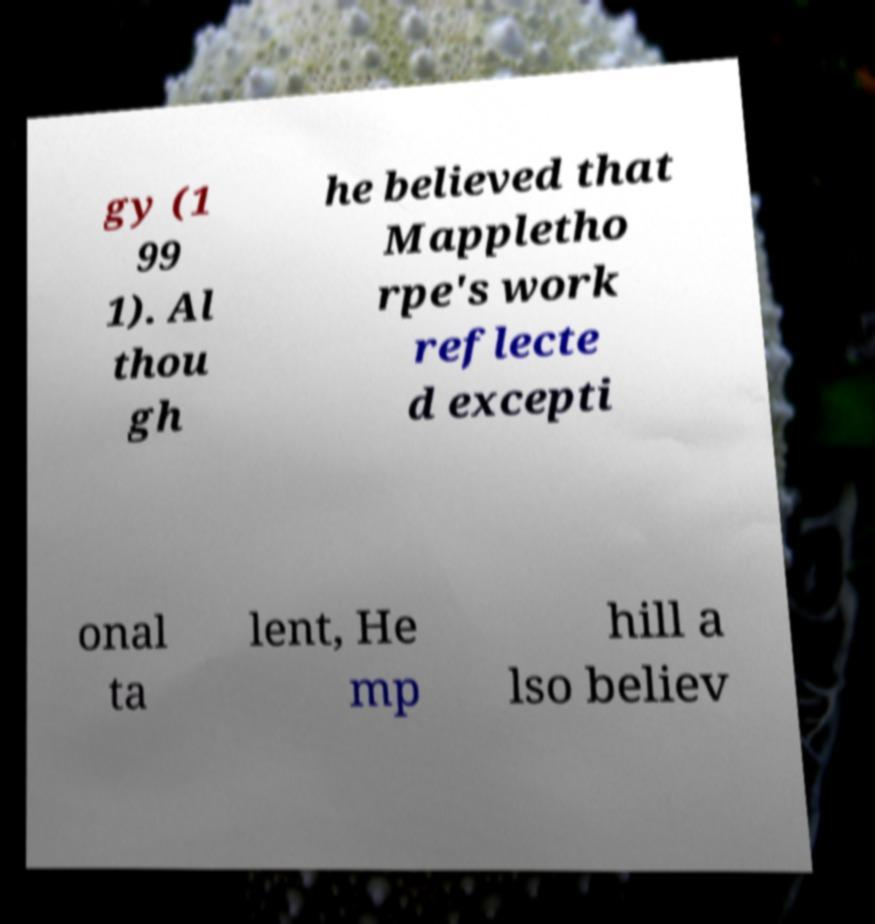Could you assist in decoding the text presented in this image and type it out clearly? gy (1 99 1). Al thou gh he believed that Mappletho rpe's work reflecte d excepti onal ta lent, He mp hill a lso believ 